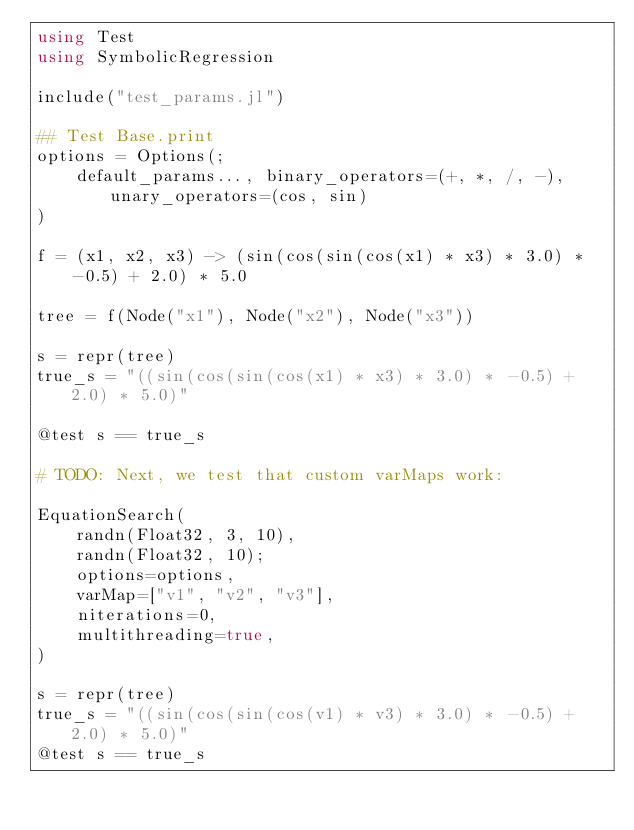<code> <loc_0><loc_0><loc_500><loc_500><_Julia_>using Test
using SymbolicRegression

include("test_params.jl")

## Test Base.print
options = Options(;
    default_params..., binary_operators=(+, *, /, -), unary_operators=(cos, sin)
)

f = (x1, x2, x3) -> (sin(cos(sin(cos(x1) * x3) * 3.0) * -0.5) + 2.0) * 5.0

tree = f(Node("x1"), Node("x2"), Node("x3"))

s = repr(tree)
true_s = "((sin(cos(sin(cos(x1) * x3) * 3.0) * -0.5) + 2.0) * 5.0)"

@test s == true_s

# TODO: Next, we test that custom varMaps work:

EquationSearch(
    randn(Float32, 3, 10),
    randn(Float32, 10);
    options=options,
    varMap=["v1", "v2", "v3"],
    niterations=0,
    multithreading=true,
)

s = repr(tree)
true_s = "((sin(cos(sin(cos(v1) * v3) * 3.0) * -0.5) + 2.0) * 5.0)"
@test s == true_s
</code> 